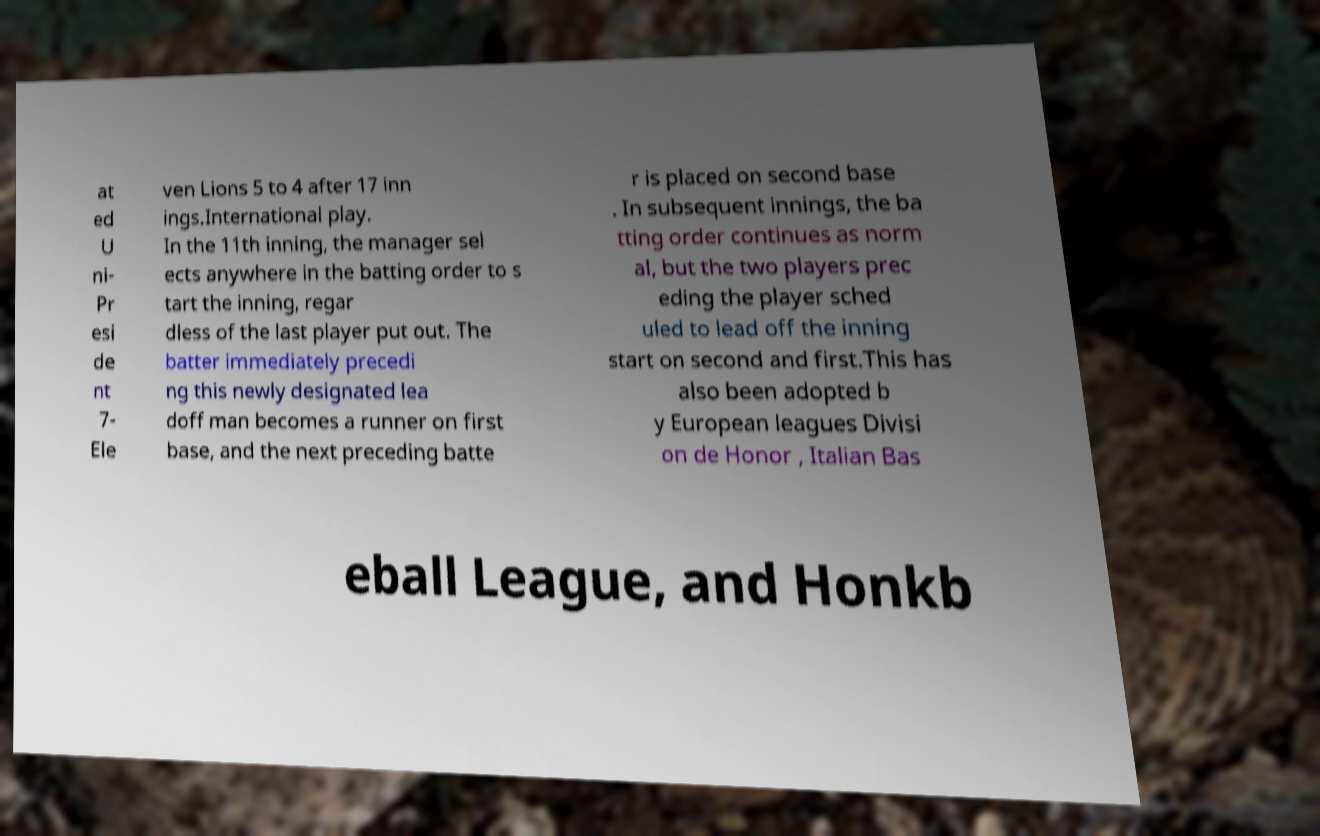What messages or text are displayed in this image? I need them in a readable, typed format. at ed U ni- Pr esi de nt 7- Ele ven Lions 5 to 4 after 17 inn ings.International play. In the 11th inning, the manager sel ects anywhere in the batting order to s tart the inning, regar dless of the last player put out. The batter immediately precedi ng this newly designated lea doff man becomes a runner on first base, and the next preceding batte r is placed on second base . In subsequent innings, the ba tting order continues as norm al, but the two players prec eding the player sched uled to lead off the inning start on second and first.This has also been adopted b y European leagues Divisi on de Honor , Italian Bas eball League, and Honkb 